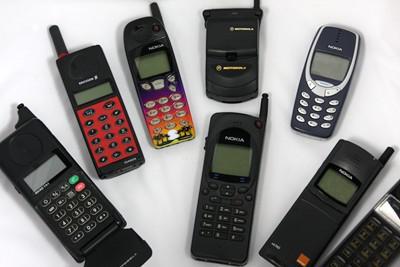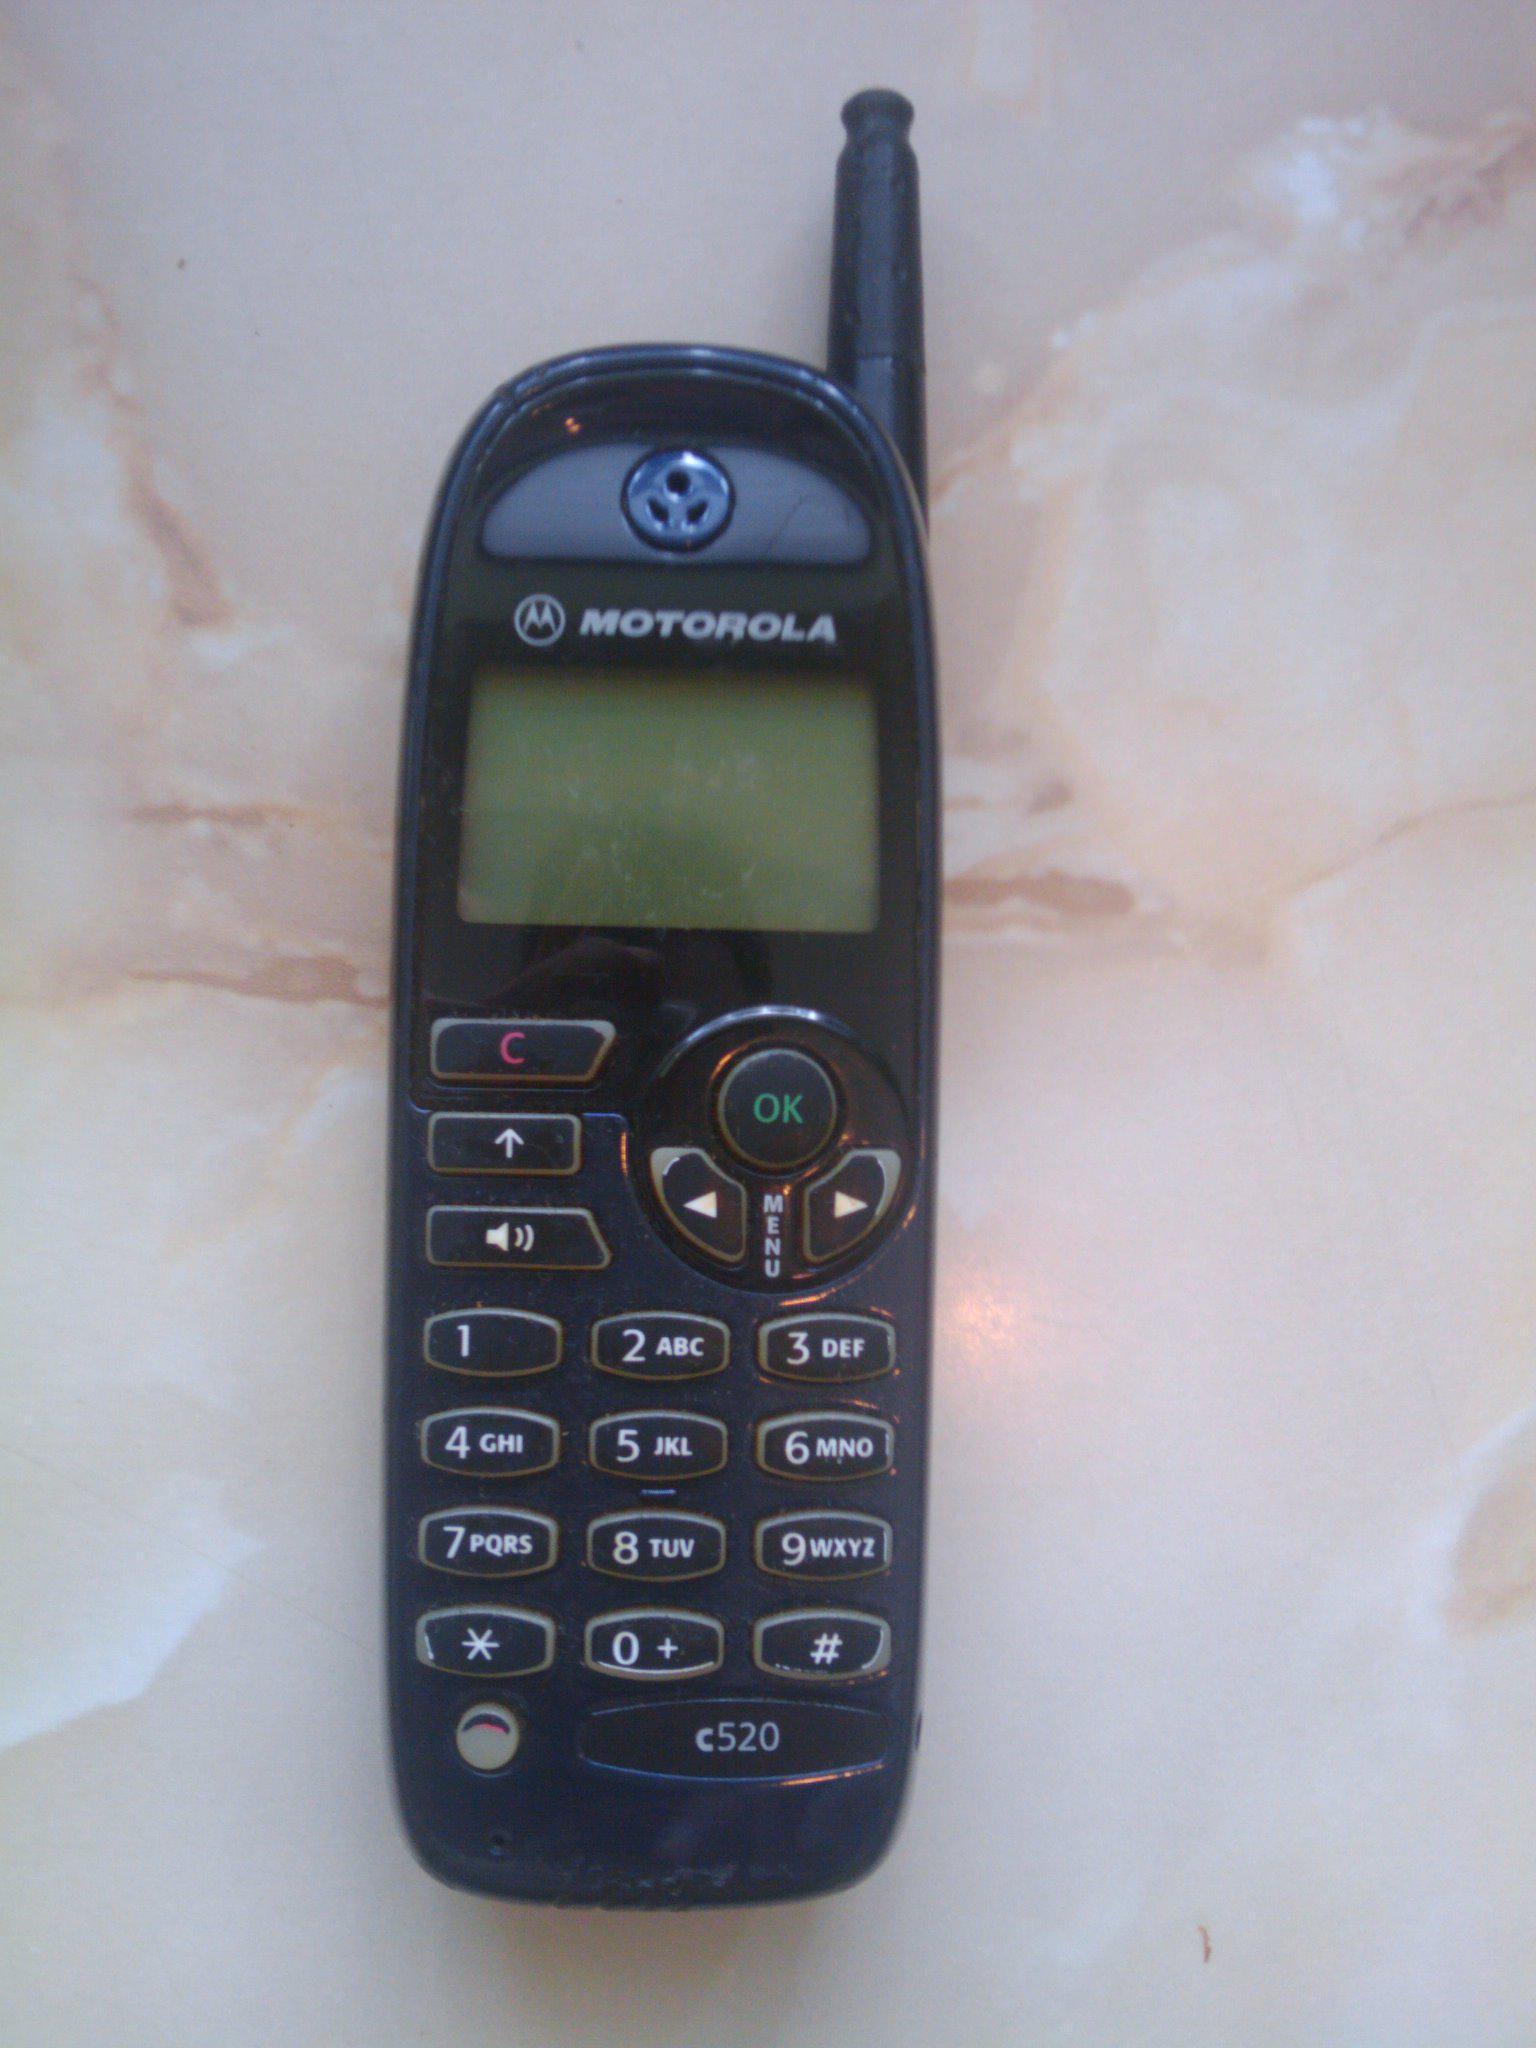The first image is the image on the left, the second image is the image on the right. Evaluate the accuracy of this statement regarding the images: "In each image, three or more cellphones with keypads and antenna knobs are shown upright and side by side.". Is it true? Answer yes or no. No. 